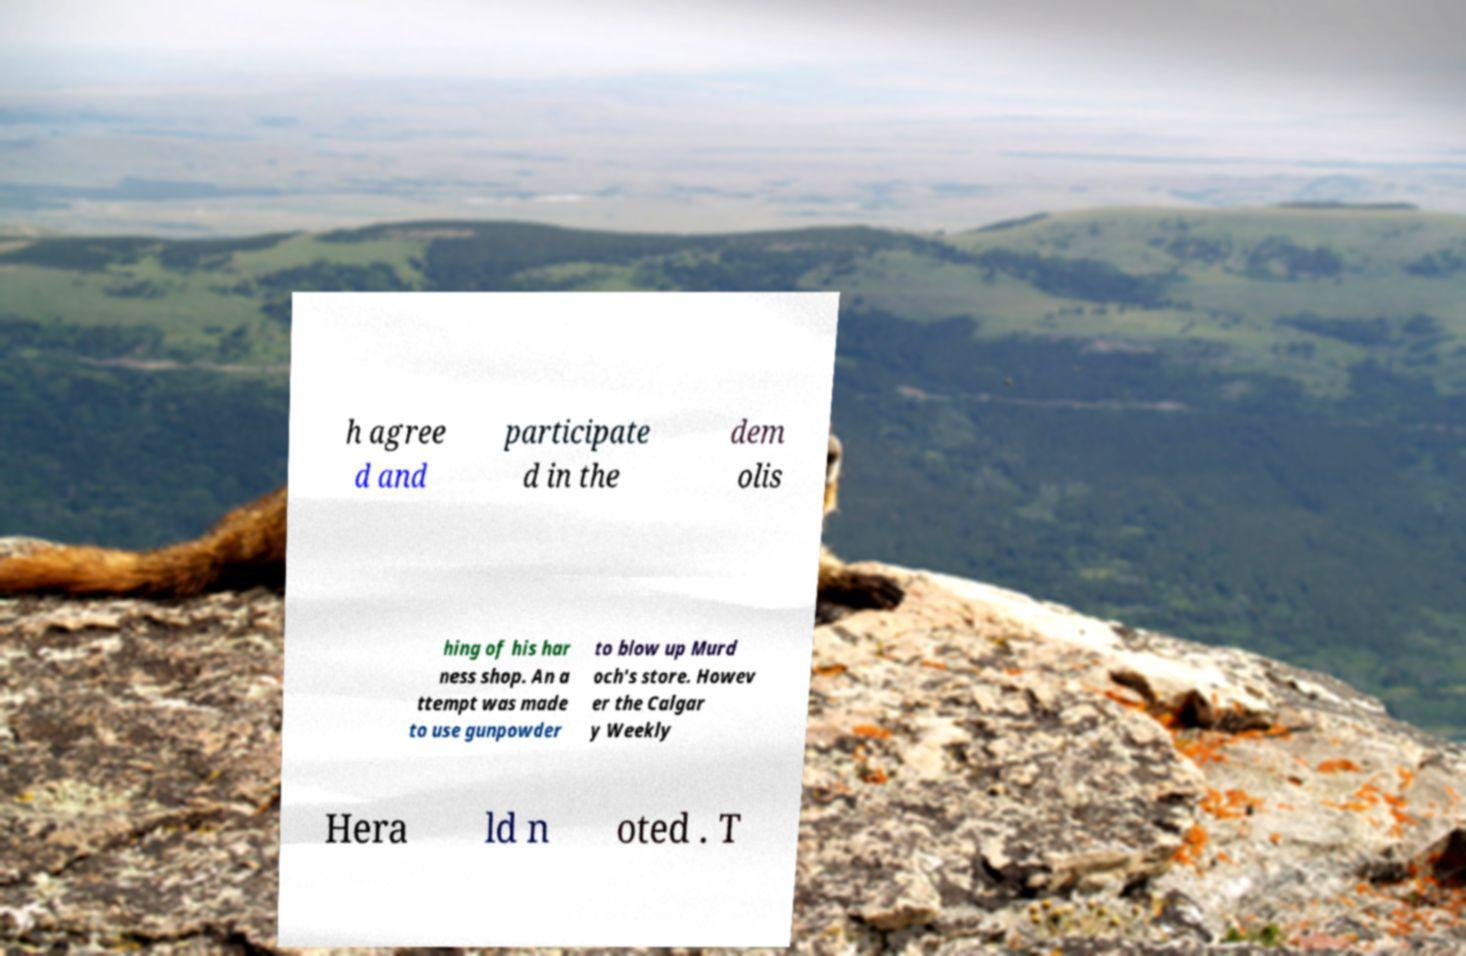Can you accurately transcribe the text from the provided image for me? h agree d and participate d in the dem olis hing of his har ness shop. An a ttempt was made to use gunpowder to blow up Murd och's store. Howev er the Calgar y Weekly Hera ld n oted . T 